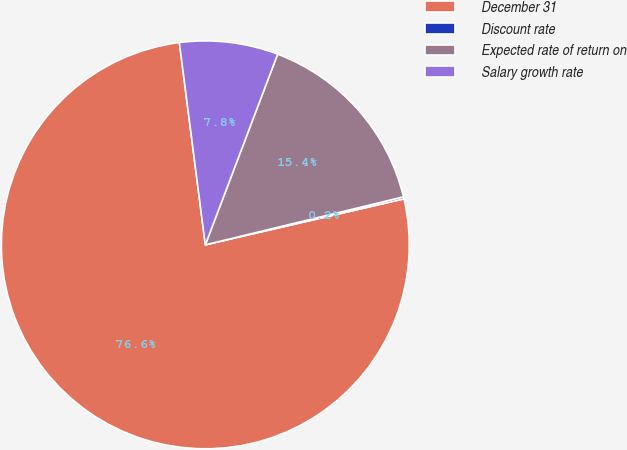Convert chart to OTSL. <chart><loc_0><loc_0><loc_500><loc_500><pie_chart><fcel>December 31<fcel>Discount rate<fcel>Expected rate of return on<fcel>Salary growth rate<nl><fcel>76.59%<fcel>0.16%<fcel>15.45%<fcel>7.8%<nl></chart> 